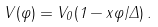<formula> <loc_0><loc_0><loc_500><loc_500>V ( \varphi ) = V _ { 0 } ( 1 - x \varphi / \Delta ) \, .</formula> 